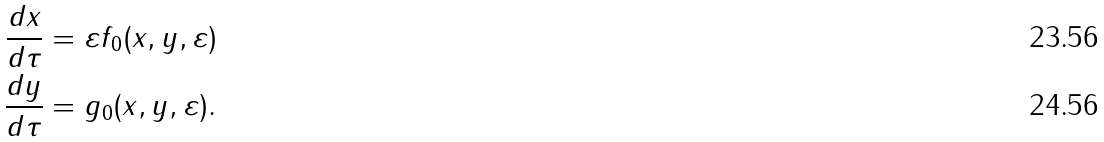<formula> <loc_0><loc_0><loc_500><loc_500>\frac { d x } { d \tau } & = \varepsilon f _ { 0 } ( x , y , \varepsilon ) \\ \frac { d y } { d \tau } & = g _ { 0 } ( x , y , \varepsilon ) .</formula> 